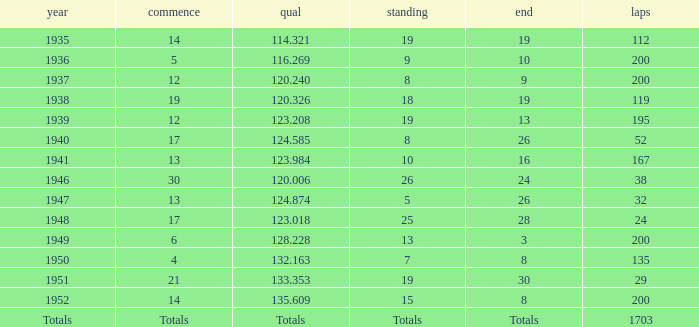In 1939, what was the finish? 13.0. 